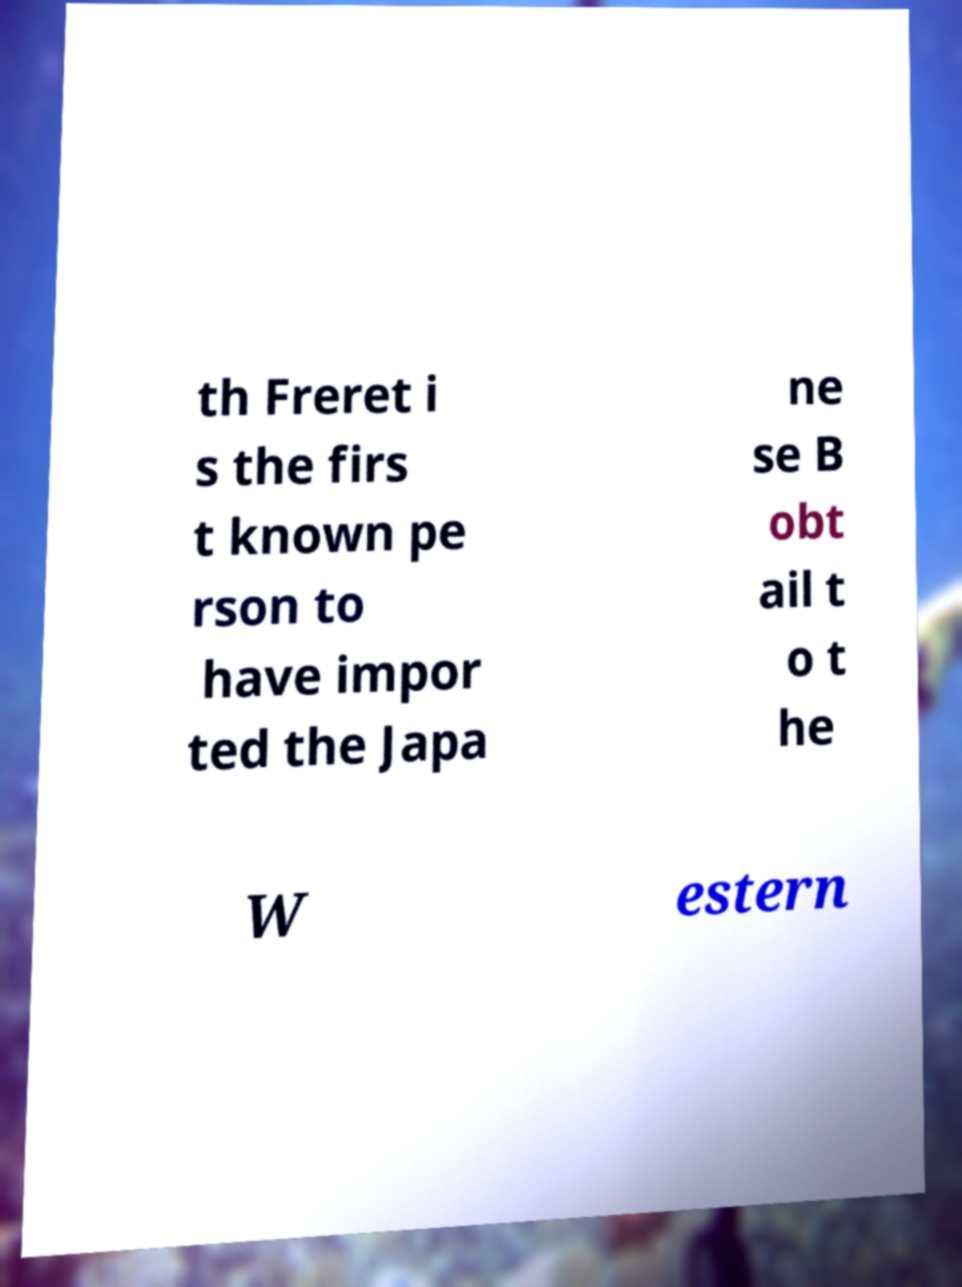I need the written content from this picture converted into text. Can you do that? th Freret i s the firs t known pe rson to have impor ted the Japa ne se B obt ail t o t he W estern 